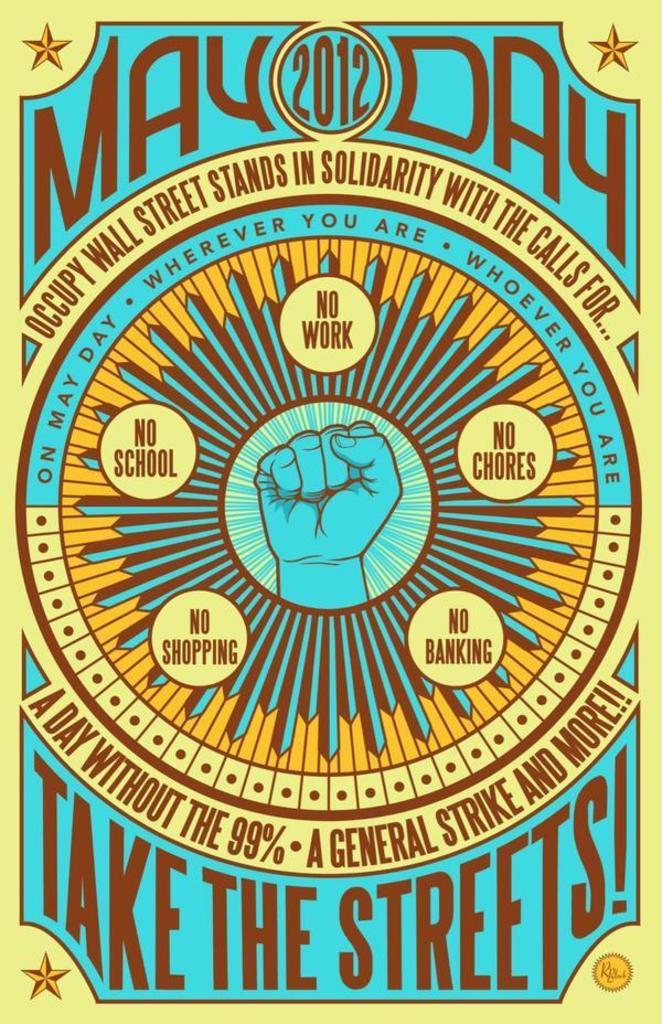<image>
Relay a brief, clear account of the picture shown. Vintage looking retro type poster in blue, yellow in brown text for May Day 2012. 